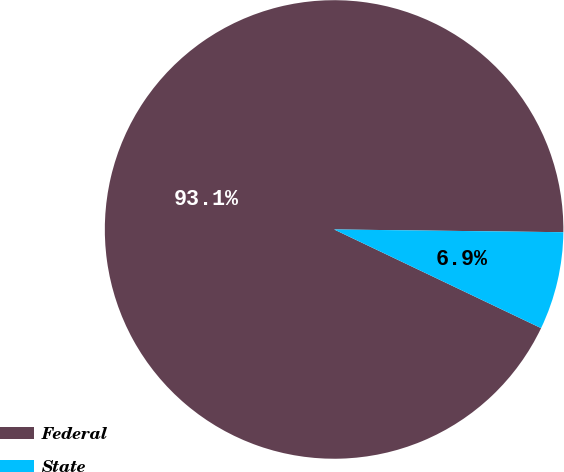Convert chart. <chart><loc_0><loc_0><loc_500><loc_500><pie_chart><fcel>Federal<fcel>State<nl><fcel>93.11%<fcel>6.89%<nl></chart> 